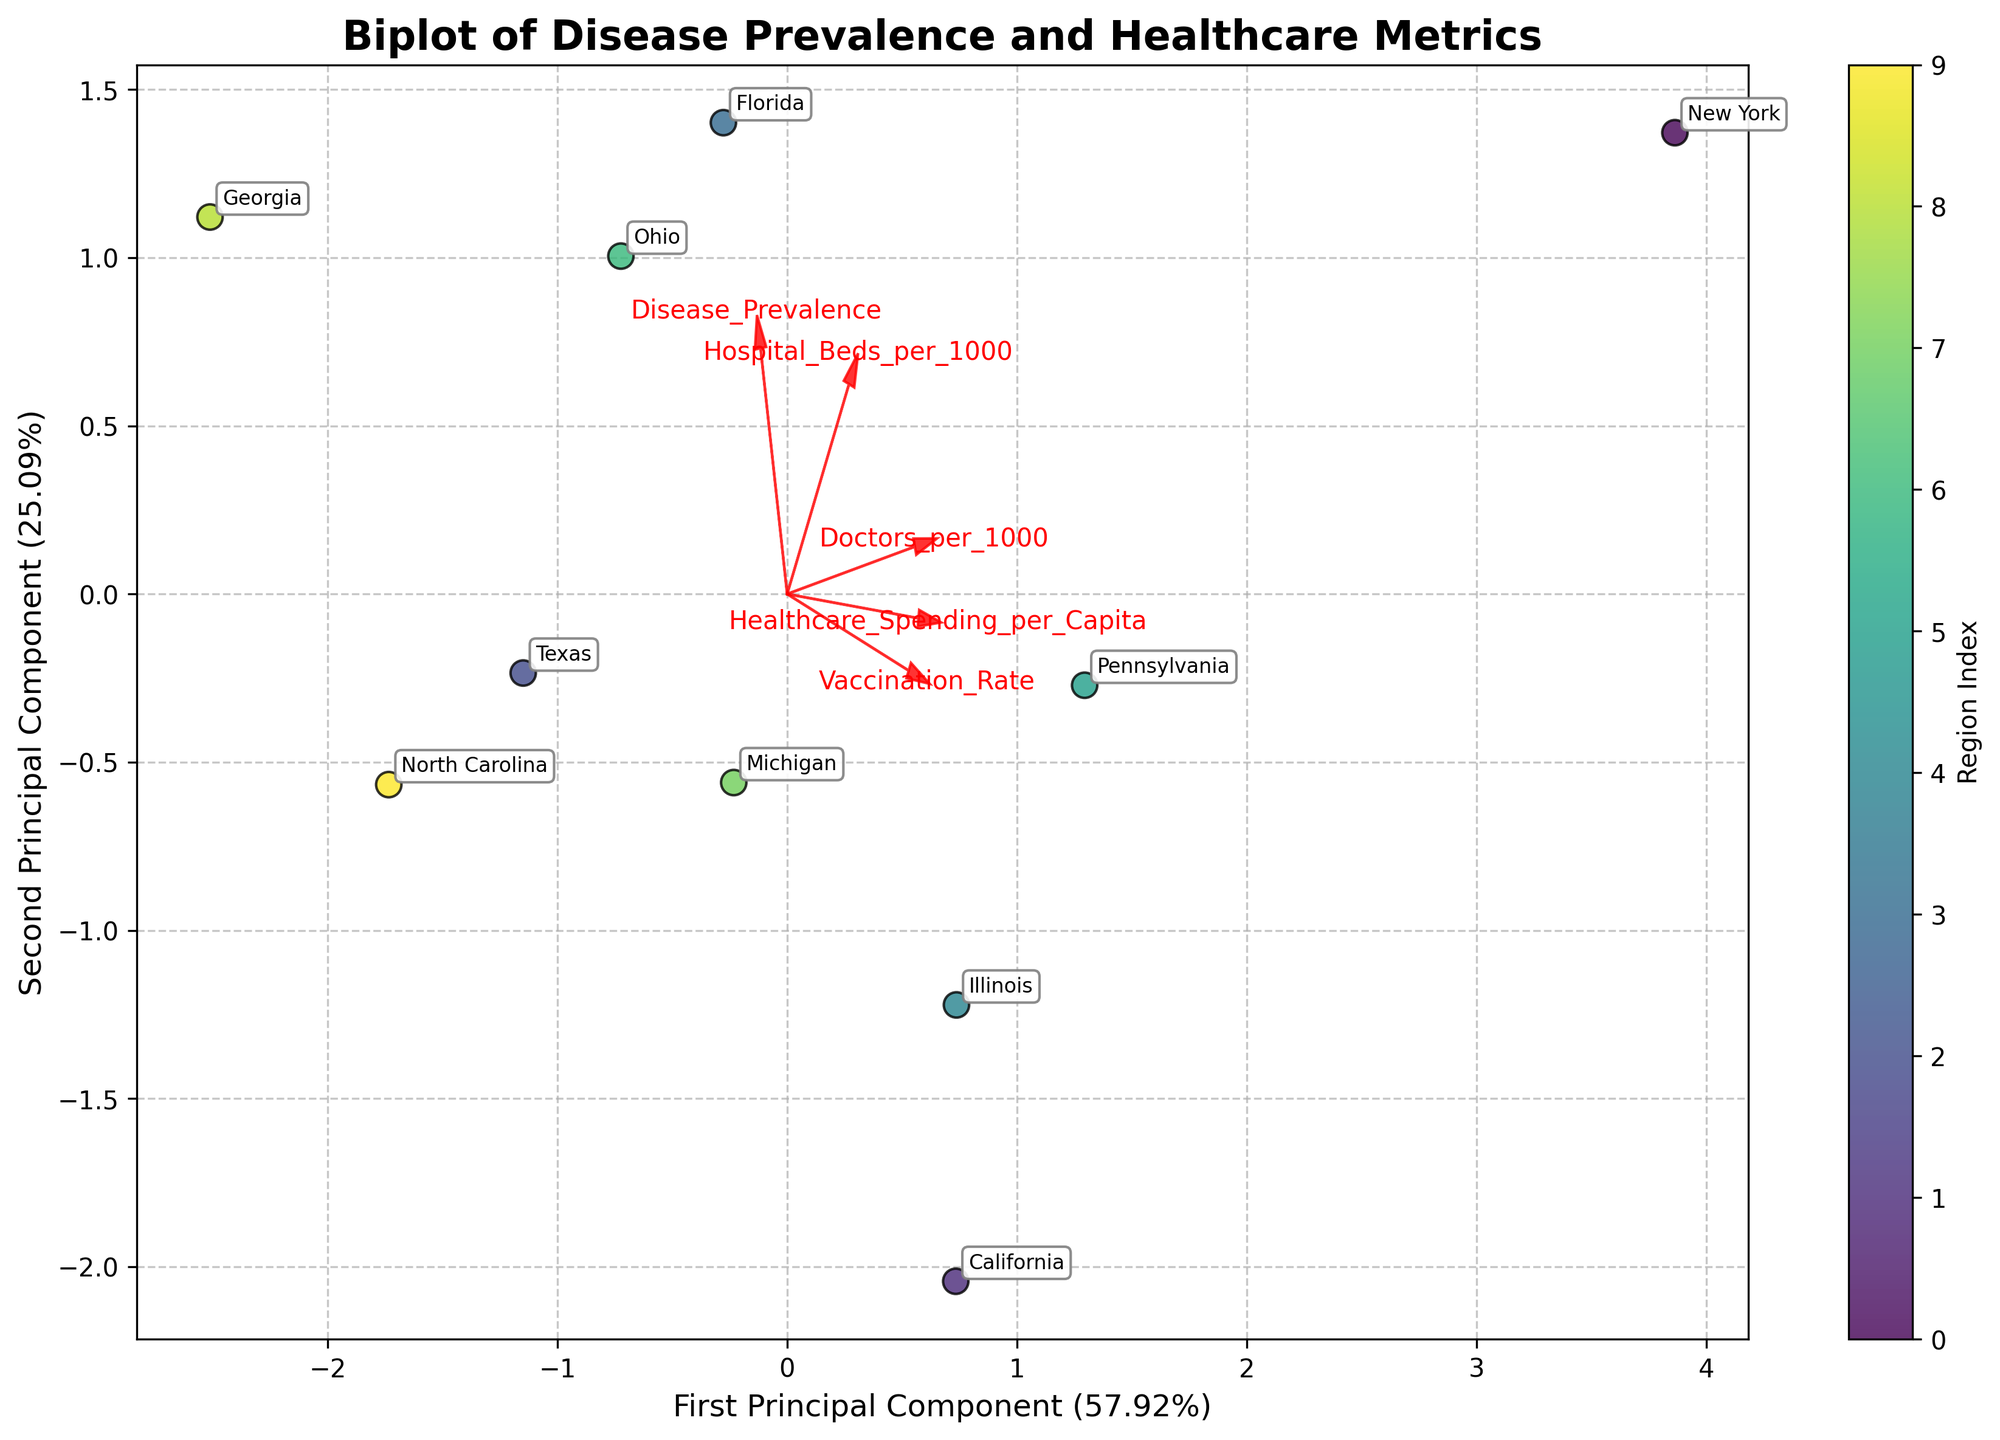How many regions are represented on the biplot? The biplot contains points annotated with region names. By counting these, we can determine the number of regions represented.
Answer: 10 What is the title of the biplot? The title is usually found at the top of the plot in larger, boldfaced text.
Answer: Biplot of Disease Prevalence and Healthcare Metrics Which principal component explains more variance in the data? The x-axis and y-axis labels indicate the variance explained by each principal component as a percentage. By comparing these percentages, we can determine which principal component explains more variance.
Answer: First Principal Component Which region has the highest Disease Prevalence based on the biplot? To find this, look for the region label closest to the vector direction for 'Disease Prevalence' as it trends positively away from the origin.
Answer: Florida Between New York and California, which region has a higher Doctor per 1000 ratio? Observe the relative positions of the New York and California points in relation to the 'Doctors_per_1000' vector direction.
Answer: New York How are Vaccination Rate and Healthcare Spending per Capita aligned in the biplot? Assess how the vectors for 'Vaccination_Rate' and 'Healthcare_Spending_per_Capita' are oriented relative to each other.
Answer: Aligned similarly What is one insight about Texas based on its position in the biplot? By examining Texas's placement and the proximity of its point to the vectors, we can infer relationships about Texas's performance on these metrics.
Answer: Mid-level Disease Prevalence and moderate Hospital Beds per 1000 Which metric appears to be most strongly correlated with the first principal component? Look at which feature vector aligns most closely with the first principal component axis, indicating the strongest correlation.
Answer: Healthcare_Spending_per_Capita Do the majority of regions cluster together or spread apart on the biplot? By observing the general distribution of the points, one can tell if the regions tend to cluster or are more dispersed across the plot.
Answer: Cluster together Which region ranks lower on the Vaccination Rate but higher on Hospital Beds per 1000? Locate regions near the 'Vaccination_Rate' vector end with negative values and compare them to positions relative to 'Hospital_Beds_per_1000'.
Answer: Ohio 